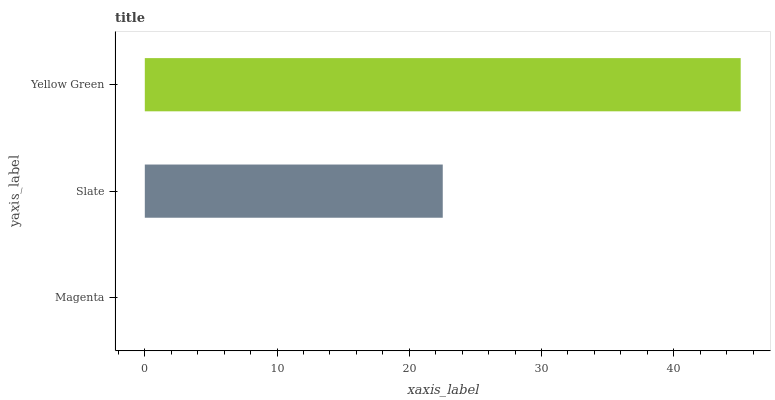Is Magenta the minimum?
Answer yes or no. Yes. Is Yellow Green the maximum?
Answer yes or no. Yes. Is Slate the minimum?
Answer yes or no. No. Is Slate the maximum?
Answer yes or no. No. Is Slate greater than Magenta?
Answer yes or no. Yes. Is Magenta less than Slate?
Answer yes or no. Yes. Is Magenta greater than Slate?
Answer yes or no. No. Is Slate less than Magenta?
Answer yes or no. No. Is Slate the high median?
Answer yes or no. Yes. Is Slate the low median?
Answer yes or no. Yes. Is Magenta the high median?
Answer yes or no. No. Is Yellow Green the low median?
Answer yes or no. No. 